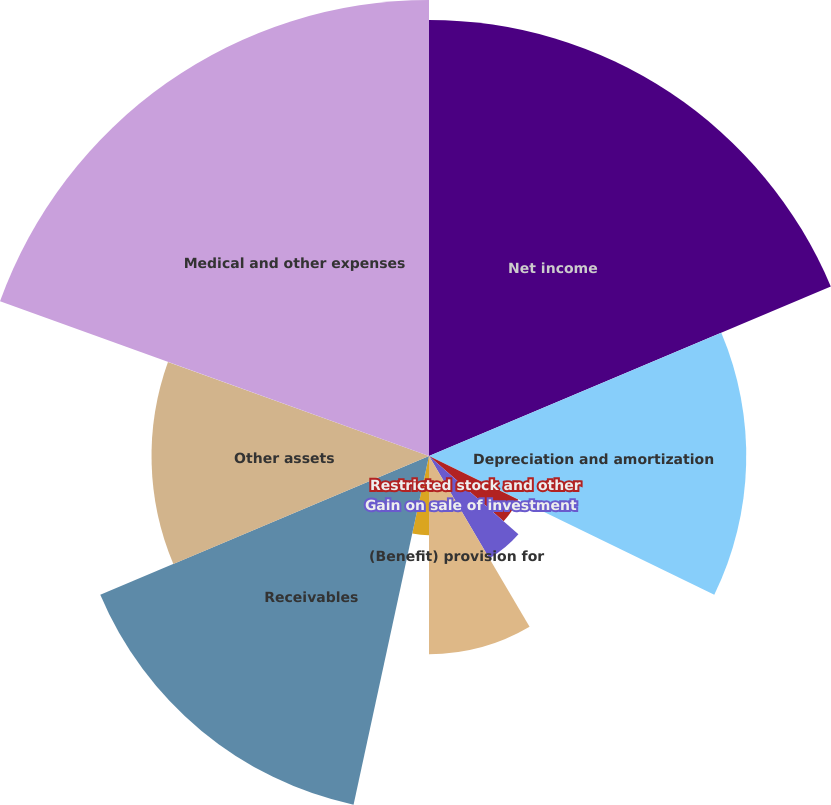Convert chart. <chart><loc_0><loc_0><loc_500><loc_500><pie_chart><fcel>Net income<fcel>Depreciation and amortization<fcel>Restricted stock and other<fcel>Loss (gain) on sale of<fcel>Gain on sale of investment<fcel>(Benefit) provision for<fcel>Provision for doubtful<fcel>Receivables<fcel>Other assets<fcel>Medical and other expenses<nl><fcel>18.64%<fcel>13.56%<fcel>4.24%<fcel>0.0%<fcel>5.08%<fcel>8.47%<fcel>3.39%<fcel>15.25%<fcel>11.86%<fcel>19.49%<nl></chart> 